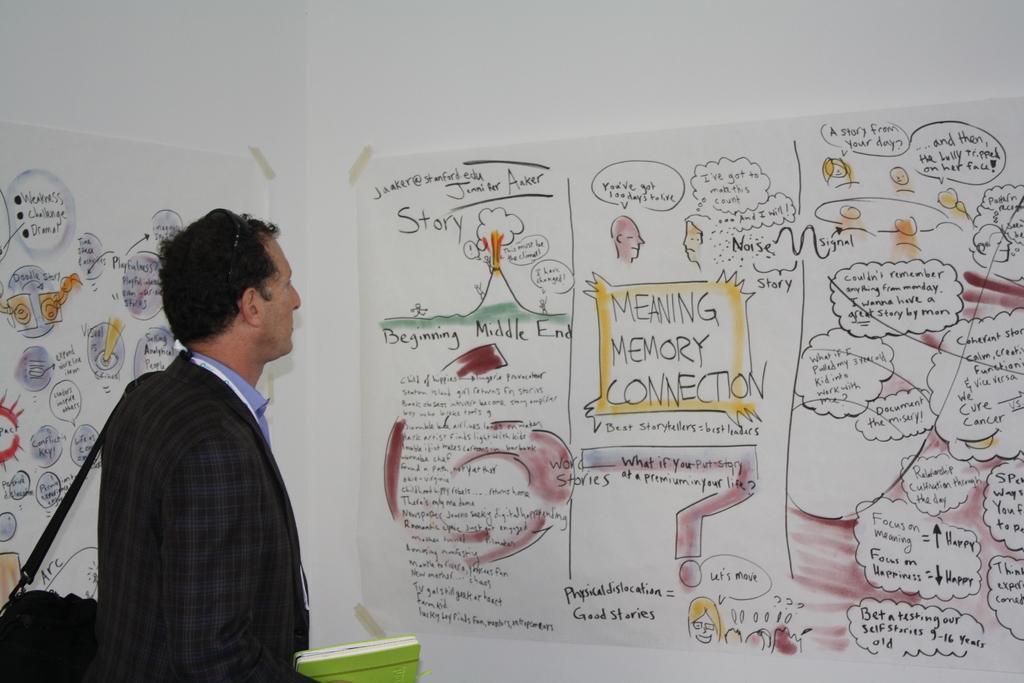<image>
Create a compact narrative representing the image presented. A man is looking at a large paper taped to a wall that says, 'Meaning Memory Connection', in the middle. 